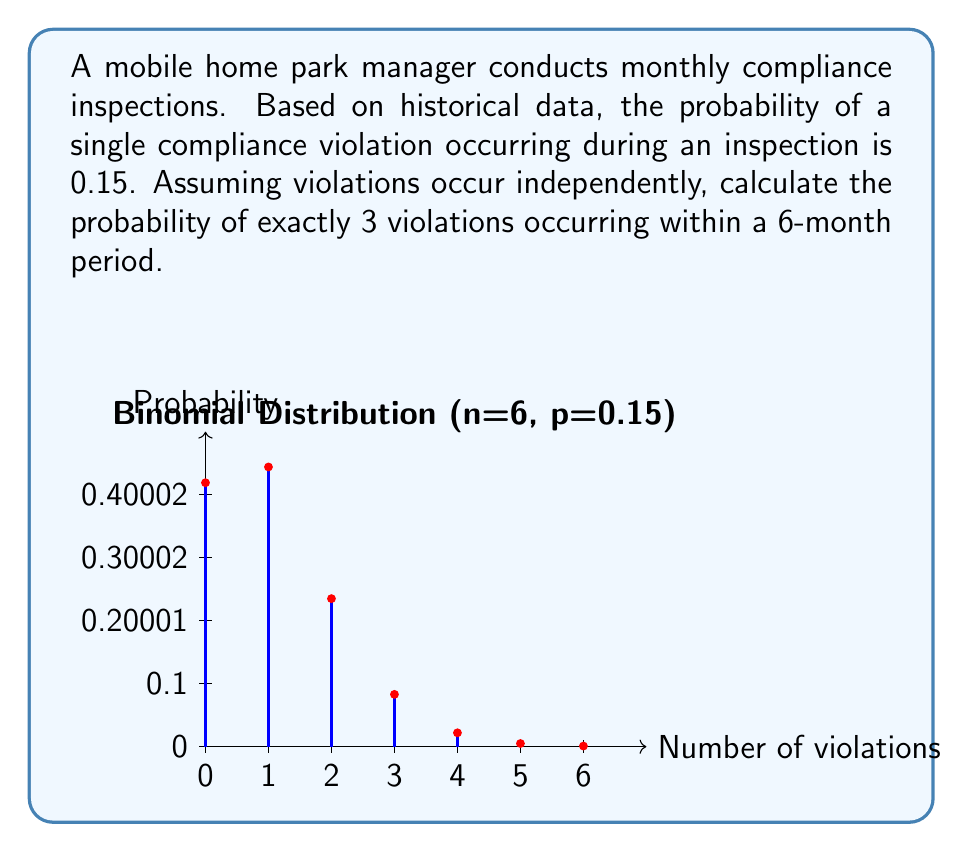Teach me how to tackle this problem. To solve this problem, we can use the Binomial distribution, which models the number of successes in a fixed number of independent trials.

Let X be the random variable representing the number of violations in 6 months.

Given:
- n = 6 (number of months/trials)
- p = 0.15 (probability of a violation in a single month)
- k = 3 (exact number of violations we're interested in)

The probability mass function for the Binomial distribution is:

$$ P(X = k) = \binom{n}{k} p^k (1-p)^{n-k} $$

Where $\binom{n}{k}$ is the binomial coefficient, calculated as:

$$ \binom{n}{k} = \frac{n!}{k!(n-k)!} $$

Step 1: Calculate the binomial coefficient
$$ \binom{6}{3} = \frac{6!}{3!(6-3)!} = \frac{6 \cdot 5 \cdot 4}{3 \cdot 2 \cdot 1} = 20 $$

Step 2: Calculate $p^k$ and $(1-p)^{n-k}$
$$ p^k = 0.15^3 = 0.003375 $$
$$ (1-p)^{n-k} = 0.85^3 = 0.614125 $$

Step 3: Apply the probability mass function
$$ P(X = 3) = 20 \cdot 0.003375 \cdot 0.614125 = 0.0414634375 $$

Therefore, the probability of exactly 3 violations occurring within a 6-month period is approximately 0.0415 or 4.15%.
Answer: $0.0415$ or $4.15\%$ 